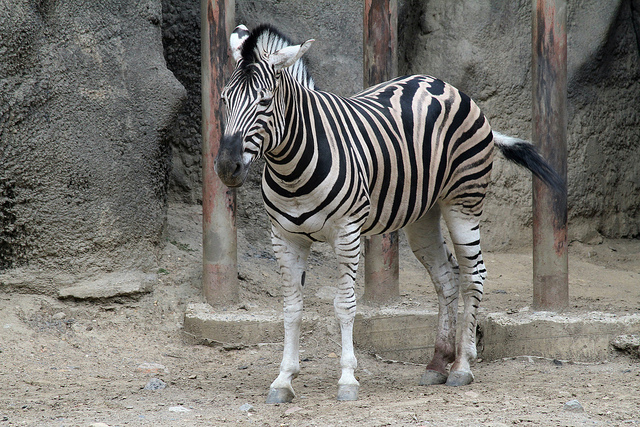Is this zebra in a zoo? While I cannot provide a definitive answer solely based on the image, visible elements such as the structured barriers and the lack of natural surroundings suggest that the zebra could be in a controlled environment like a zoo. 